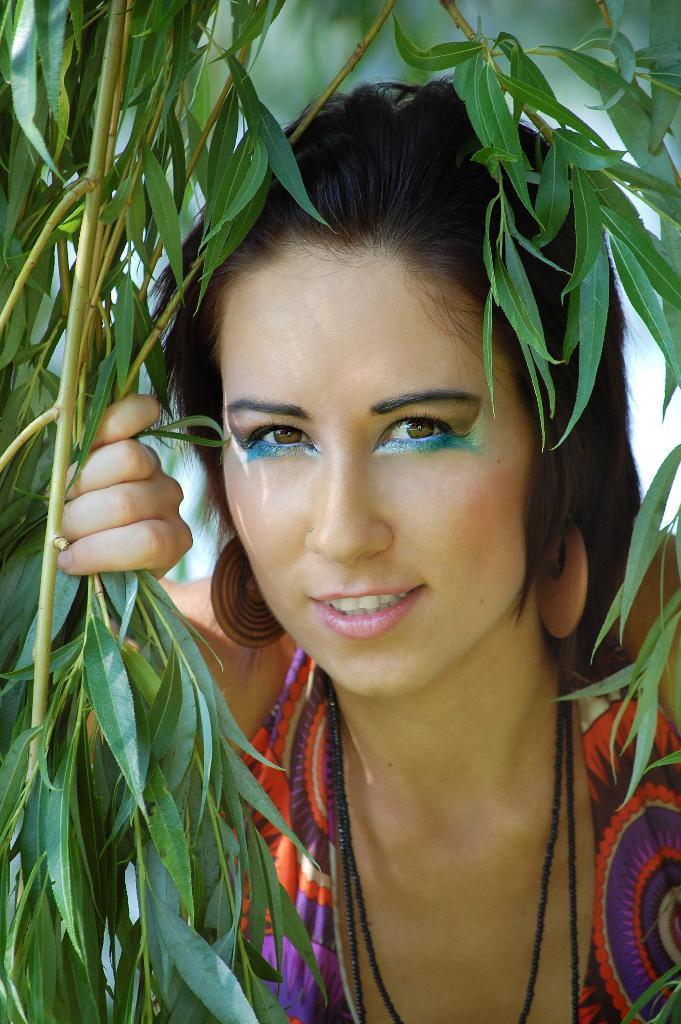How would you summarize this image in a sentence or two? In this picture, we see the woman is wearing the violet and red dress. She is smiling and she is posing for the photo. Beside her, we see the trees. In the background, it is in white and green color. This picture is blurred in the background. 